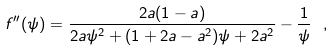<formula> <loc_0><loc_0><loc_500><loc_500>f ^ { \prime \prime } ( \psi ) = \frac { 2 a ( 1 - a ) } { 2 a \psi ^ { 2 } + ( 1 + 2 a - a ^ { 2 } ) \psi + 2 a ^ { 2 } } - \frac { 1 } { \psi } \ ,</formula> 